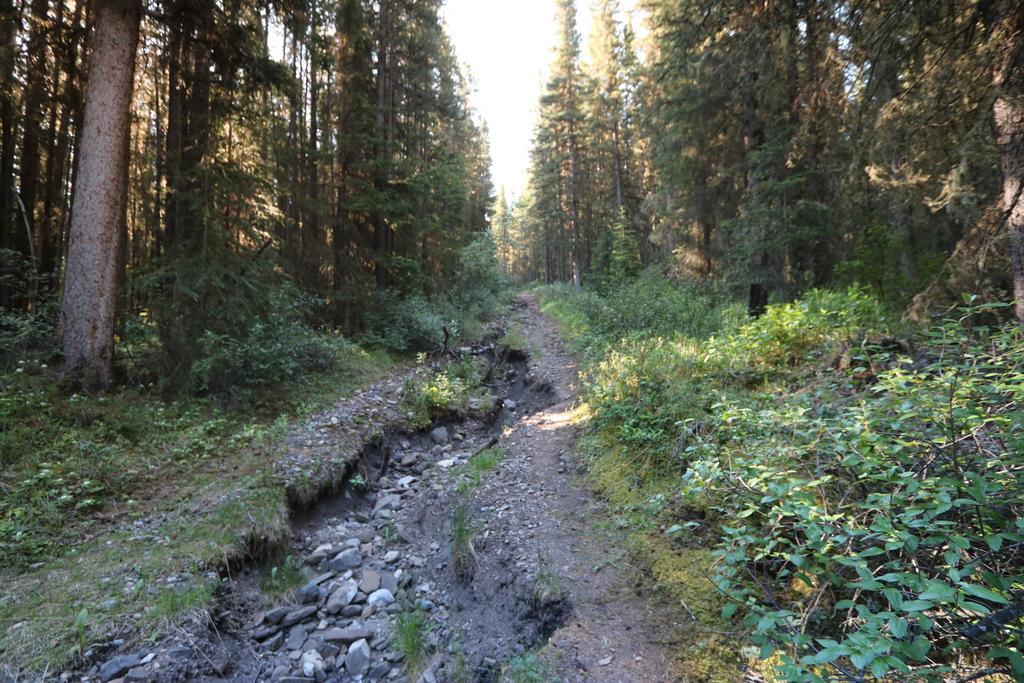Please provide a concise description of this image. This is the picture of a forest. In this image there are trees. At the top there is sky. At the bottom there is ground and there is grass and there are stones. 